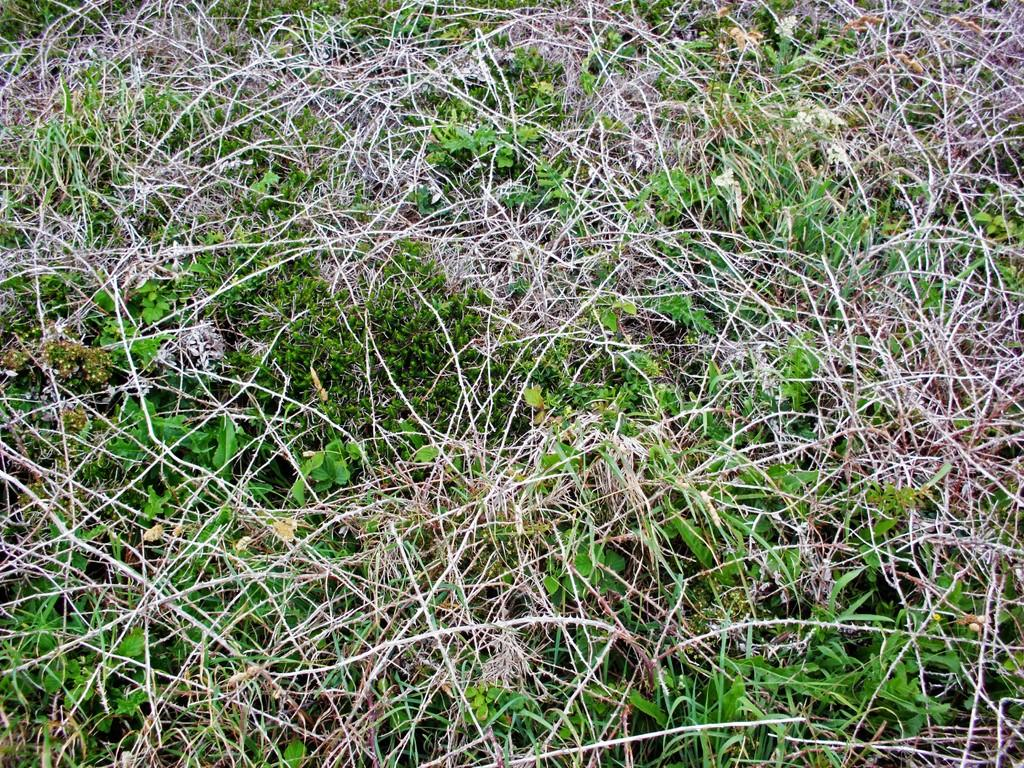What types of grass are present in the image? The image contains dry grass and green grass. Can you describe any other objects or elements in the image? Yes, there is a seed visible in the image. What type of pancake is being served on the sidewalk in the image? There is no pancake or sidewalk present in the image; it features dry and green grass with a seed. 